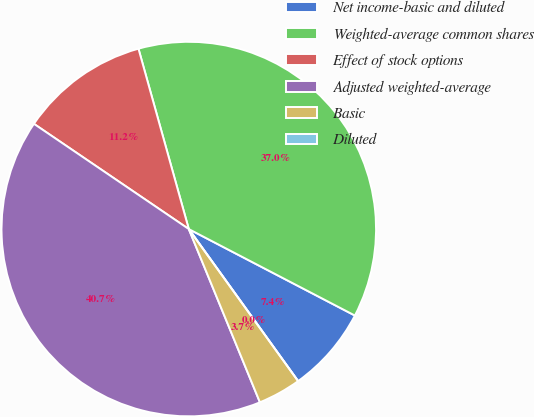Convert chart to OTSL. <chart><loc_0><loc_0><loc_500><loc_500><pie_chart><fcel>Net income-basic and diluted<fcel>Weighted-average common shares<fcel>Effect of stock options<fcel>Adjusted weighted-average<fcel>Basic<fcel>Diluted<nl><fcel>7.44%<fcel>36.97%<fcel>11.17%<fcel>40.7%<fcel>3.72%<fcel>0.0%<nl></chart> 